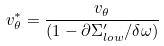Convert formula to latex. <formula><loc_0><loc_0><loc_500><loc_500>v _ { \theta } ^ { \ast } = \frac { v _ { \theta } } { ( 1 - \partial \Sigma _ { l o w } ^ { \prime } / \delta \omega ) }</formula> 